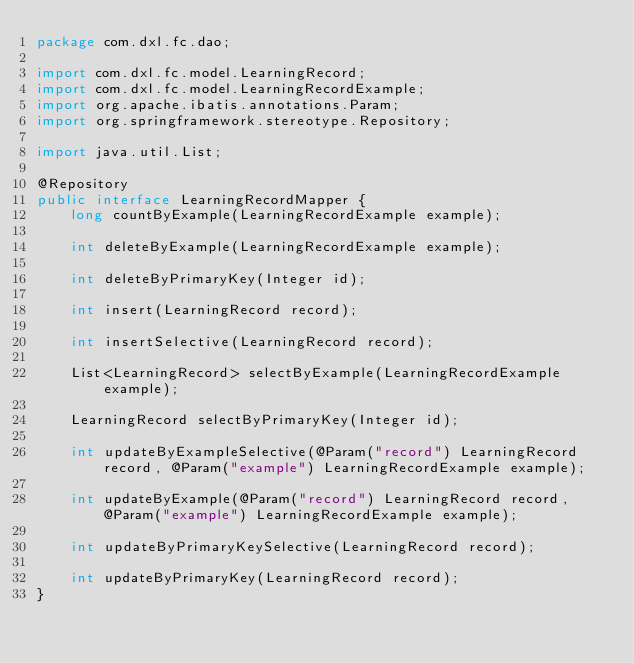<code> <loc_0><loc_0><loc_500><loc_500><_Java_>package com.dxl.fc.dao;

import com.dxl.fc.model.LearningRecord;
import com.dxl.fc.model.LearningRecordExample;
import org.apache.ibatis.annotations.Param;
import org.springframework.stereotype.Repository;

import java.util.List;

@Repository
public interface LearningRecordMapper {
    long countByExample(LearningRecordExample example);

    int deleteByExample(LearningRecordExample example);

    int deleteByPrimaryKey(Integer id);

    int insert(LearningRecord record);

    int insertSelective(LearningRecord record);

    List<LearningRecord> selectByExample(LearningRecordExample example);

    LearningRecord selectByPrimaryKey(Integer id);

    int updateByExampleSelective(@Param("record") LearningRecord record, @Param("example") LearningRecordExample example);

    int updateByExample(@Param("record") LearningRecord record, @Param("example") LearningRecordExample example);

    int updateByPrimaryKeySelective(LearningRecord record);

    int updateByPrimaryKey(LearningRecord record);
}</code> 